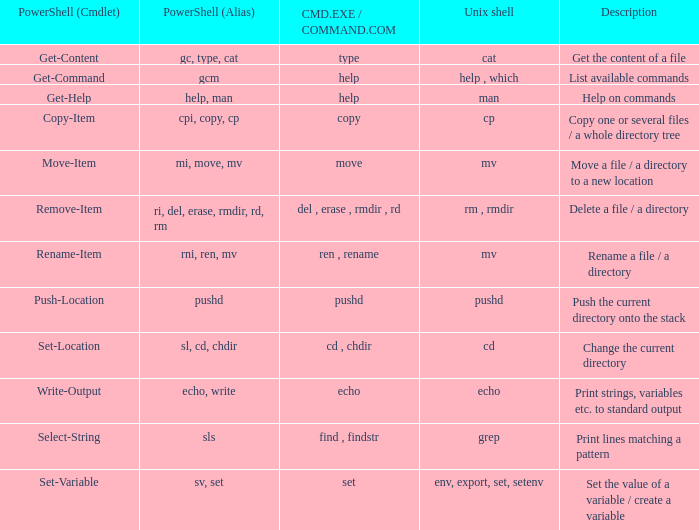What are all values of CMD.EXE / COMMAND.COM for the unix shell echo? Echo. 